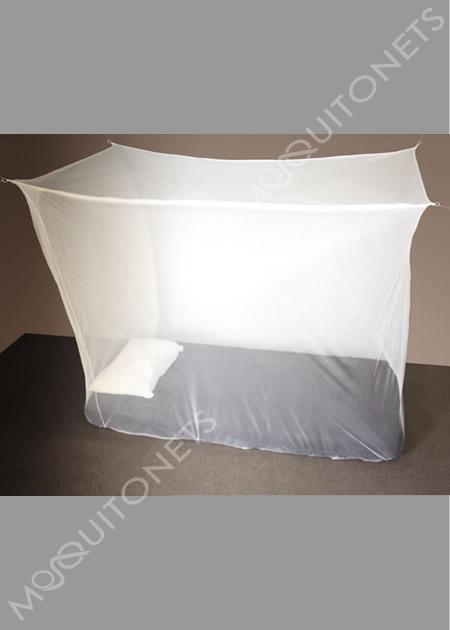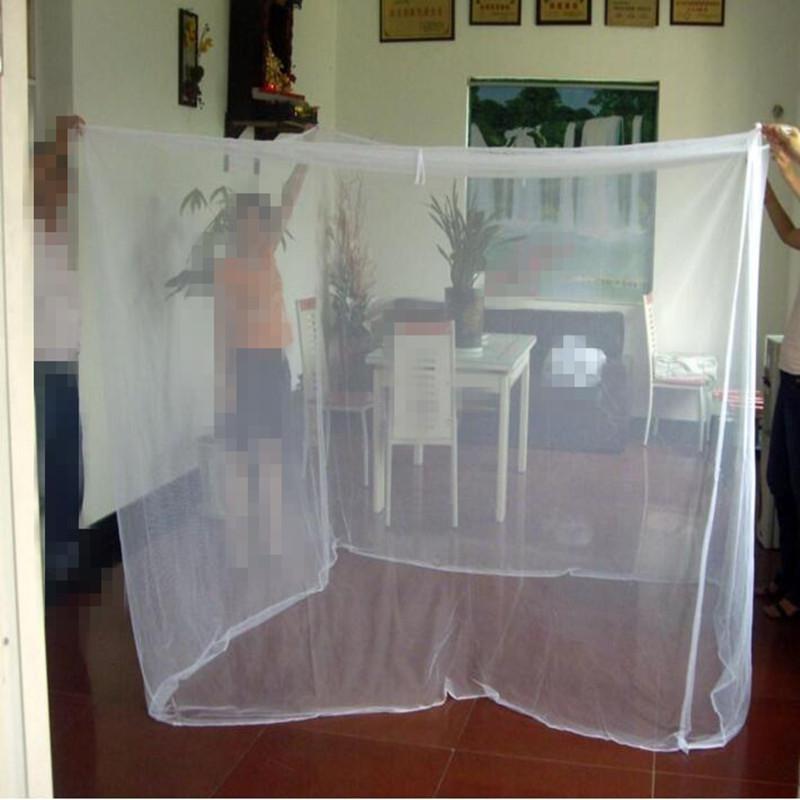The first image is the image on the left, the second image is the image on the right. Evaluate the accuracy of this statement regarding the images: "A bed with its pillow on the left and a cloth-covered table alongside it has a canopy with each corner lifted by a strap.". Is it true? Answer yes or no. No. The first image is the image on the left, the second image is the image on the right. Assess this claim about the two images: "One mattress has no blanket, the other mattress has a light (mostly white) colored blanket.". Correct or not? Answer yes or no. No. 